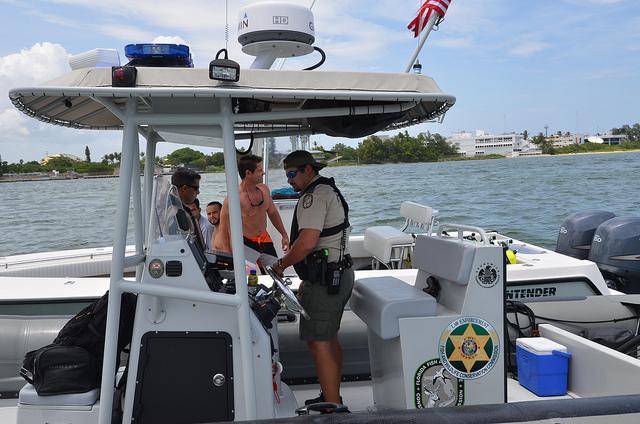What color is the cooler on the boat?
Write a very short answer. Blue. How many flags are there?
Quick response, please. 1. Is the shirtless man in trouble?
Short answer required. Yes. 